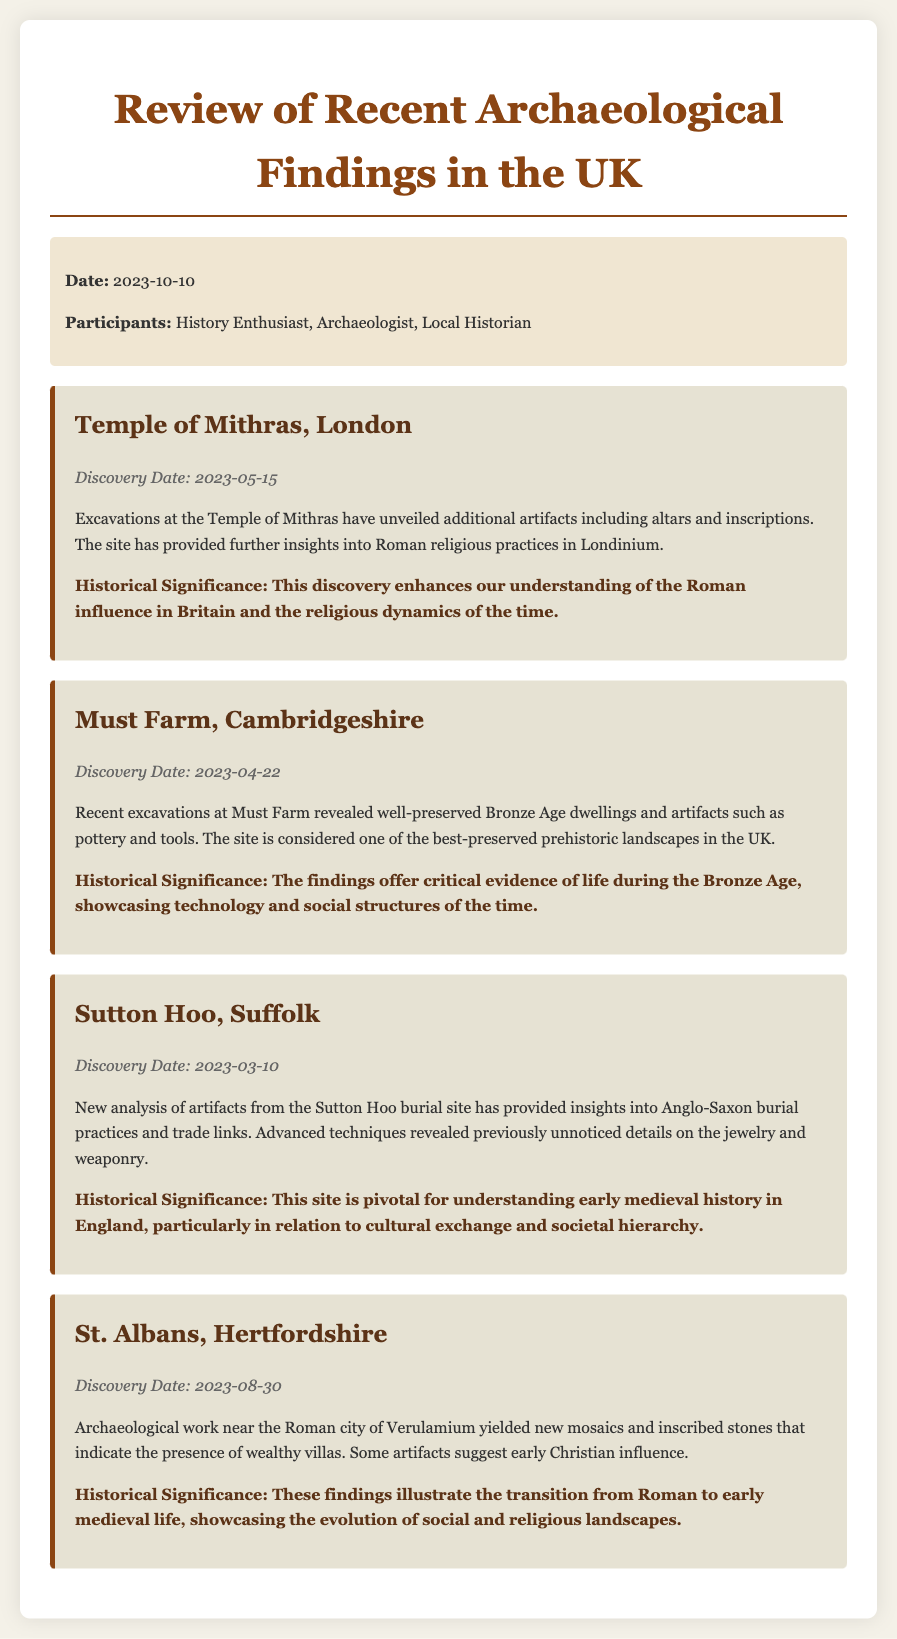What is the title of the meeting minutes? The title of the document is the main heading that summarizes its content.
Answer: Review of Recent Archaeological Findings in the UK When was the Temple of Mithras discovered? The discovery date is given specifically for the Temple of Mithras within the document.
Answer: 2023-05-15 What significant artifacts were found at Must Farm? The details include specific items discovered that reflect on the historical context of the site.
Answer: Pottery and tools What does the Sutton Hoo site provide insights into? The historical significance elaborates on what the findings at Sutton Hoo reveal about past practices.
Answer: Anglo-Saxon burial practices Which site indicates early Christian influence in its findings? The details from the site describe the nature of the artifacts uncovered that suggest religious transitions.
Answer: St. Albans, Hertfordshire How many participants attended the meeting? The participants are listed, and this requires simple counting for the answer.
Answer: Three 